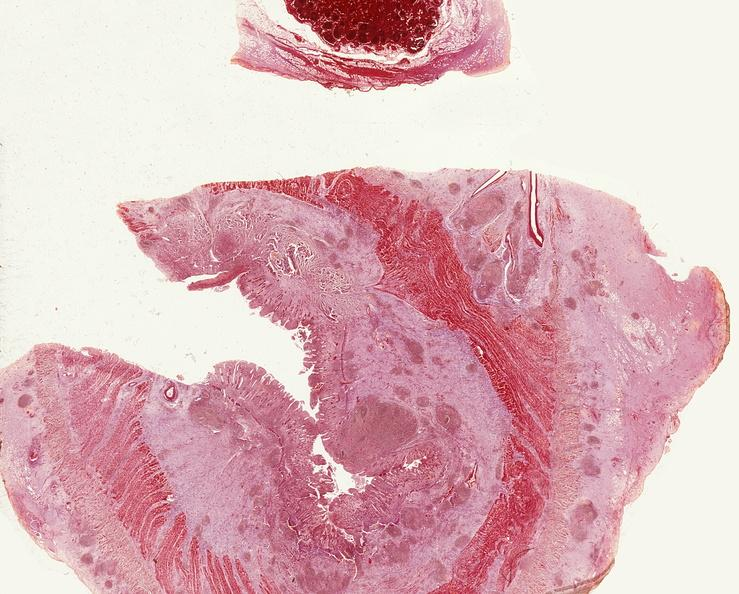where is this from?
Answer the question using a single word or phrase. Gastrointestinal system 